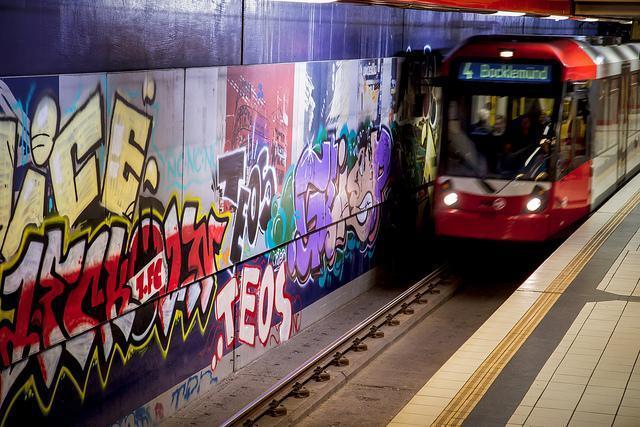How many cars are red?
Give a very brief answer. 0. 